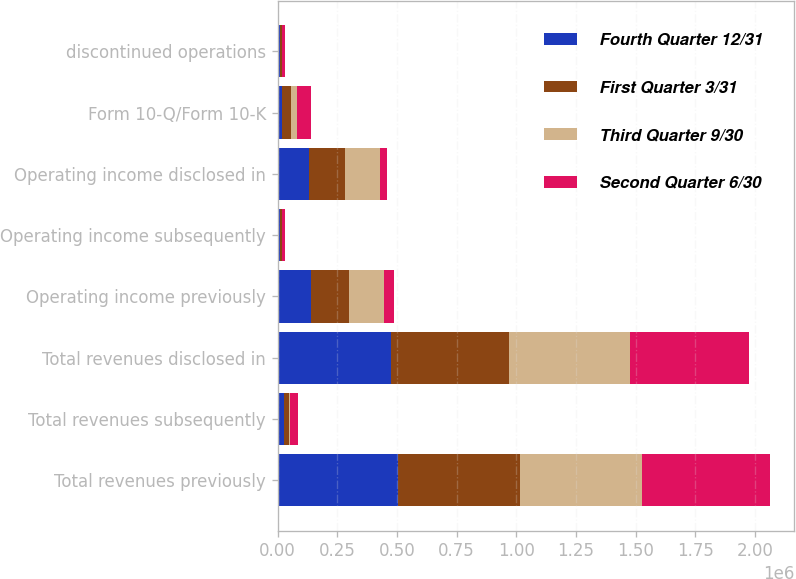Convert chart. <chart><loc_0><loc_0><loc_500><loc_500><stacked_bar_chart><ecel><fcel>Total revenues previously<fcel>Total revenues subsequently<fcel>Total revenues disclosed in<fcel>Operating income previously<fcel>Operating income subsequently<fcel>Operating income disclosed in<fcel>Form 10-Q/Form 10-K<fcel>discontinued operations<nl><fcel>Fourth Quarter 12/31<fcel>502641<fcel>26606<fcel>476035<fcel>139509<fcel>9916<fcel>129593<fcel>17934<fcel>9430<nl><fcel>First Quarter 3/31<fcel>513283<fcel>19505<fcel>493778<fcel>158356<fcel>7141<fcel>151215<fcel>39148<fcel>6909<nl><fcel>Third Quarter 9/30<fcel>511006<fcel>6269<fcel>504737<fcel>148175<fcel>2221<fcel>145954<fcel>26094<fcel>1976<nl><fcel>Second Quarter 6/30<fcel>533345<fcel>32226<fcel>501119<fcel>41056<fcel>12489<fcel>31396<fcel>57232<fcel>11850<nl></chart> 